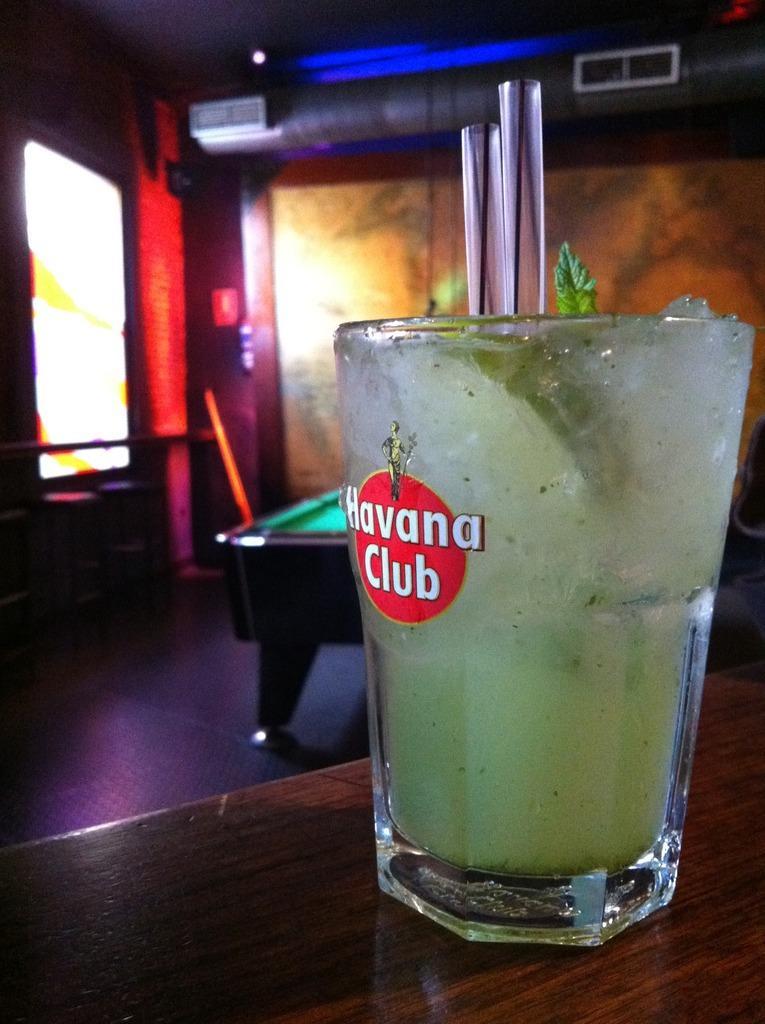Please provide a concise description of this image. In the image we can see there is a juice glass kept on the table and behind there is a billiards board. 